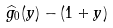Convert formula to latex. <formula><loc_0><loc_0><loc_500><loc_500>\widehat { g } _ { 0 } ( y ) - ( 1 + y )</formula> 